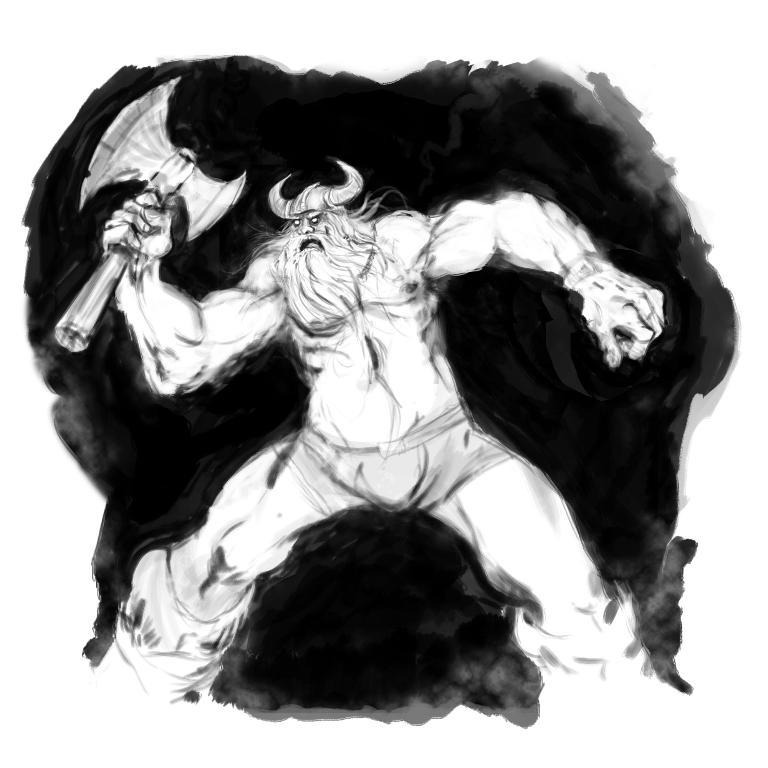What is the main subject of the image? There is a painting in the image. What is depicted in the painting? The painting depicts a person. What is the person holding in the painting? The person is holding an ax in the painting. What is the color of the background in the painting? The background of the painting is white in color. What type of pest can be seen in the painting? There is no pest visible in the painting; it depicts a person holding an ax. Can you tell me how many chess pieces are present in the painting? There are no chess pieces present in the painting; it features a person holding an ax against a white background. 